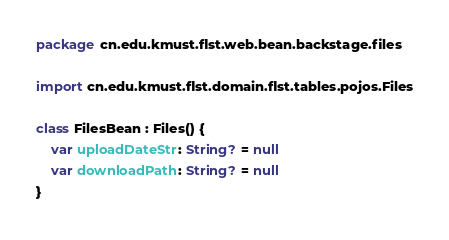Convert code to text. <code><loc_0><loc_0><loc_500><loc_500><_Kotlin_>package cn.edu.kmust.flst.web.bean.backstage.files

import cn.edu.kmust.flst.domain.flst.tables.pojos.Files

class FilesBean : Files() {
    var uploadDateStr: String? = null
    var downloadPath: String? = null
}</code> 